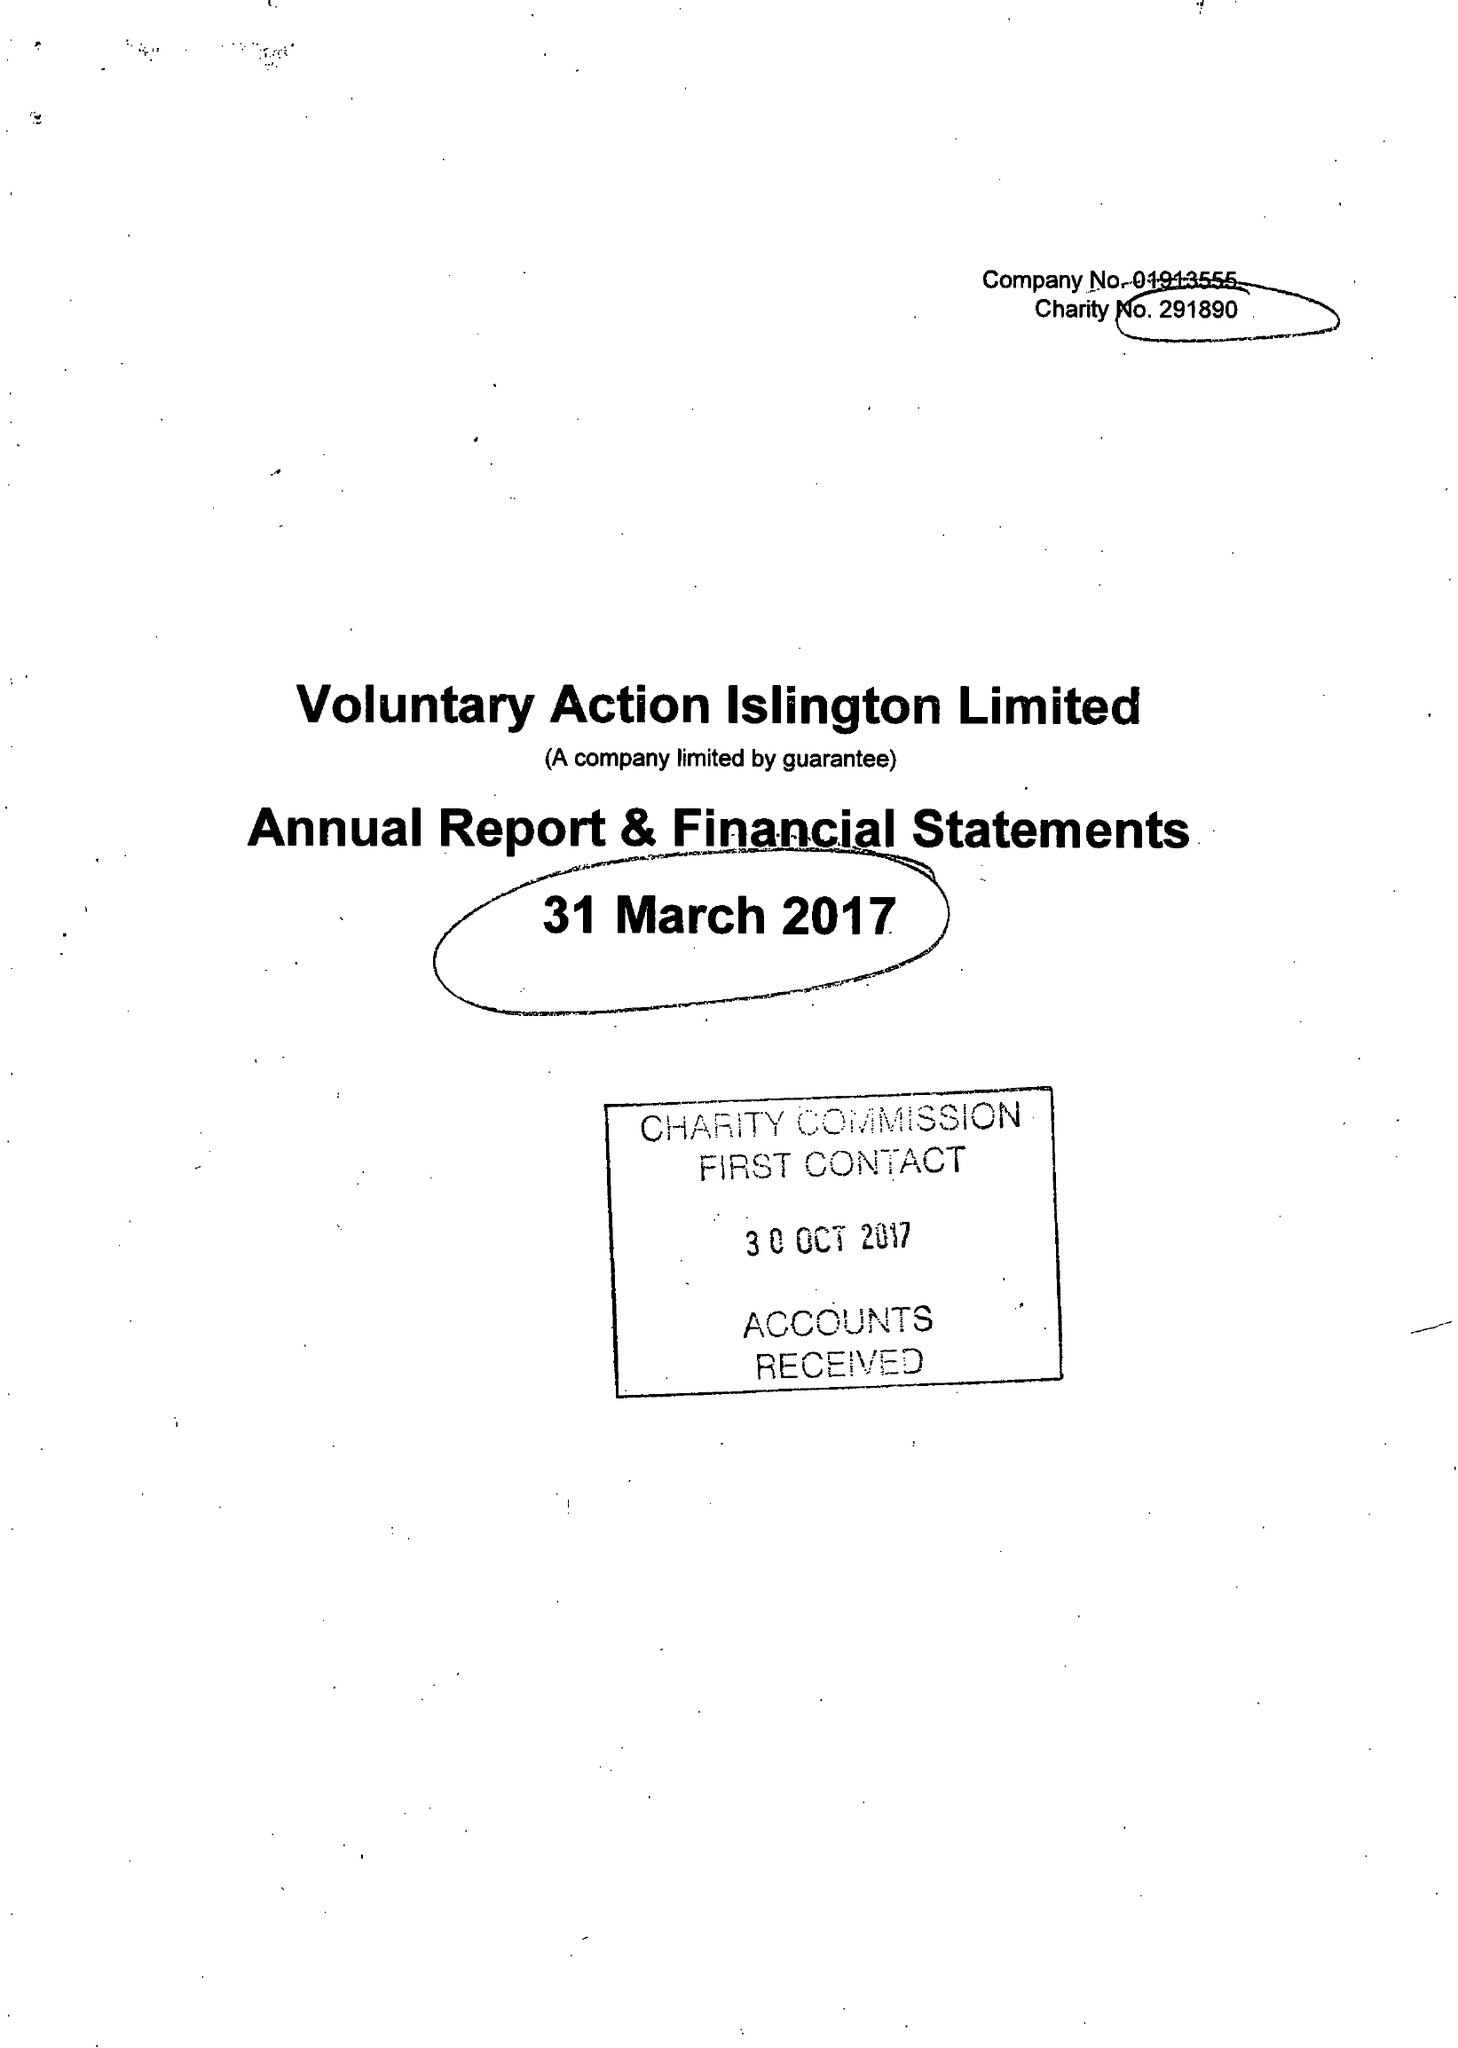What is the value for the address__postcode?
Answer the question using a single word or phrase. N1 9JP 